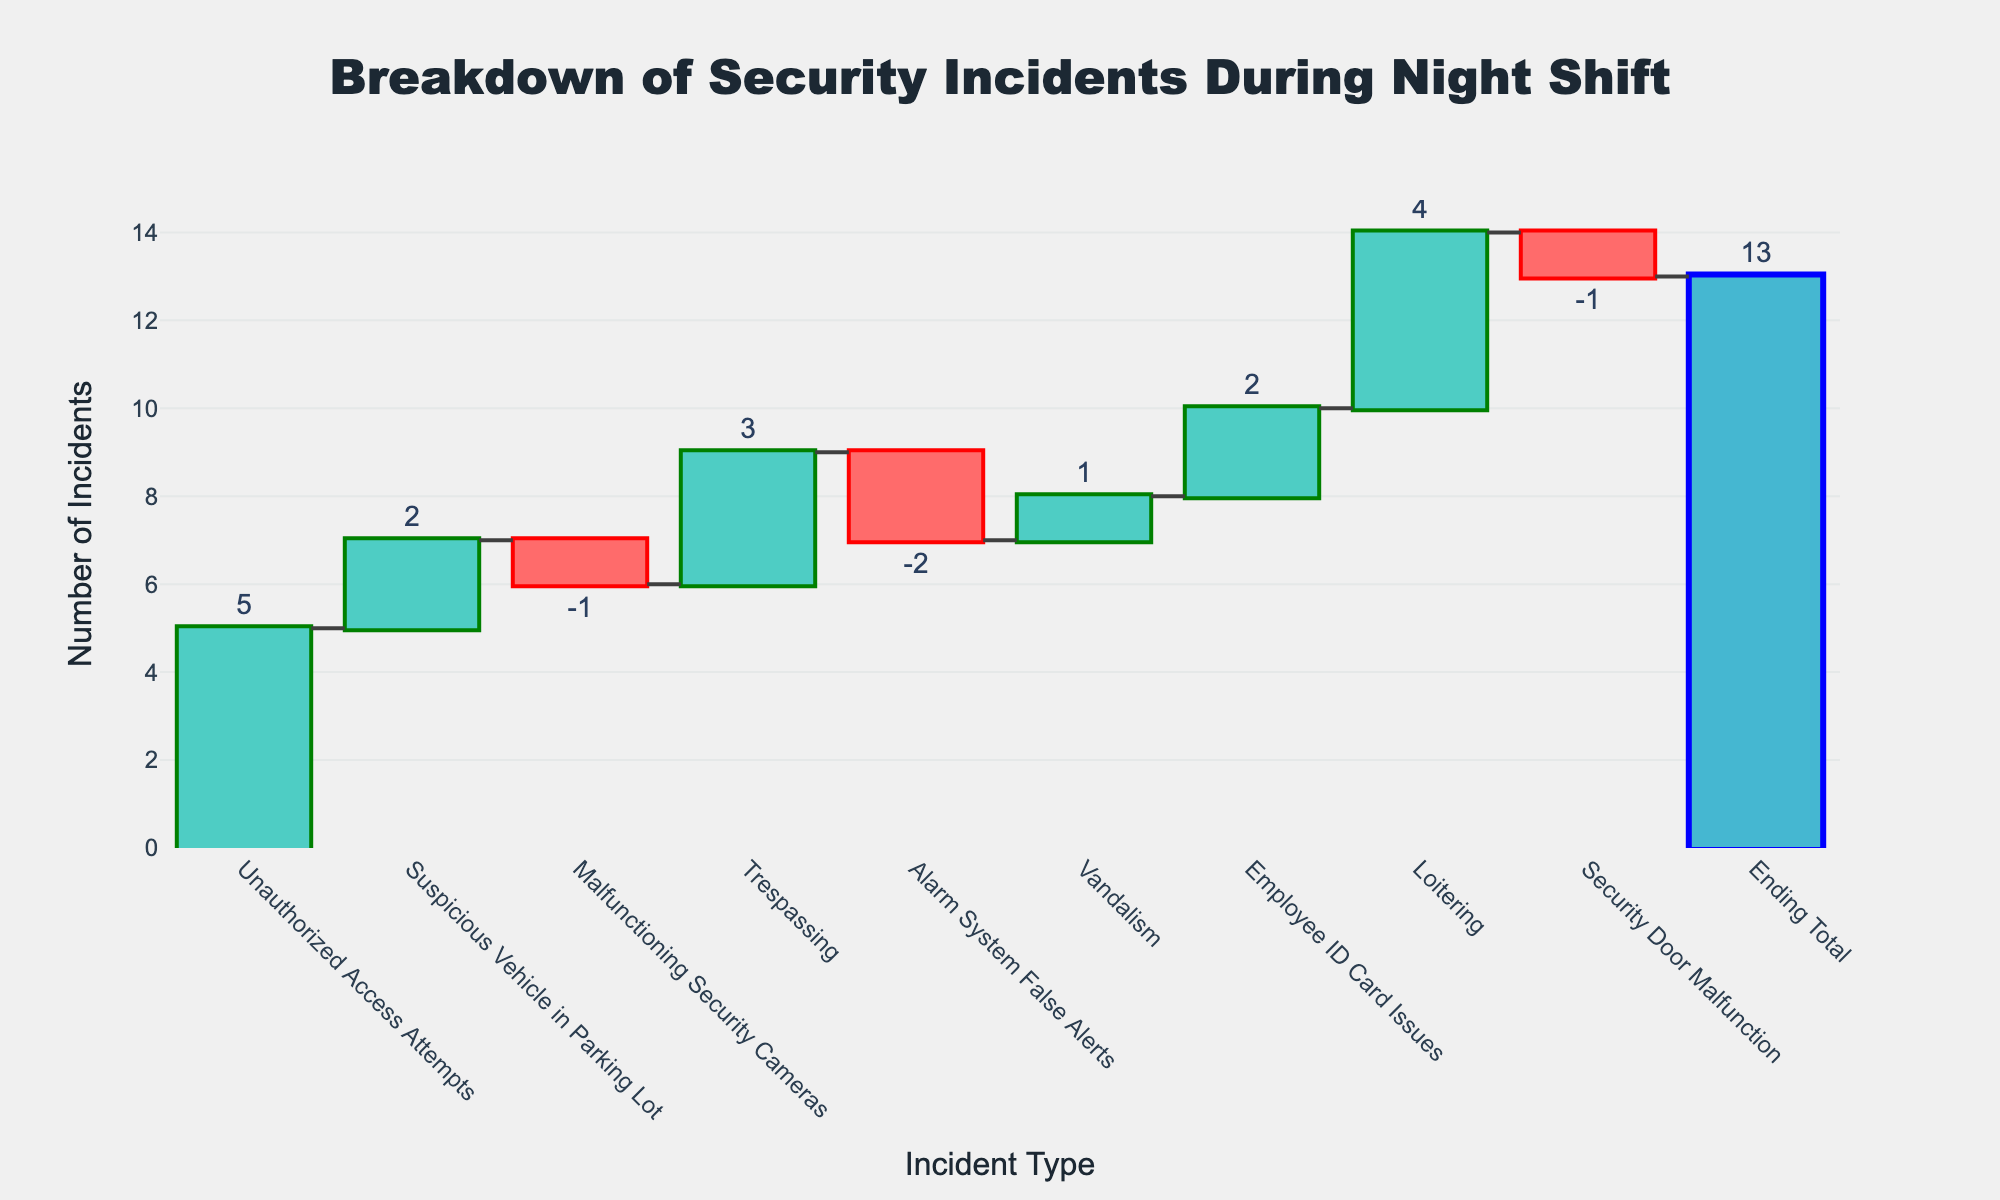What is the total number of incidents at the end of the shift? The ending total is directly indicated by the "Ending Total" bar in the chart. It represents the cumulative sum of all incidents' values.
Answer: 13 How many incidents were categorized as unauthorized access attempts? The bar labeled "Unauthorized Access Attempts" in the chart shows the value associated with this category.
Answer: 5 Which category had the lowest number of incidents? By observing the categories with negative values and comparisons between them, "Alarm System False Alerts" and "Malfunctioning Security Cameras" have the lowest values.
Answer: Alarm System False Alerts How does the sum of positive incident categories compare to the sum of negative incident categories? Positive categories: Unauthorized Access Attempts (5), Suspicious Vehicle in Parking Lot (2), Trespassing (3), Vandalism (1), Employee ID Card Issues (2), Loitering (4). Total positive = 5 + 2 + 3 + 1 + 2 + 4 = 17. Negative categories: Malfunctioning Security Cameras (-1), Alarm System False Alerts (-2), Security Door Malfunction (-1). Total negative = -1 + -2 + -1 = -4. The sum of positive incident categories is significantly higher.
Answer: 17 vs. -4 What is the cumulative number of incidents before and after accounting for the malfunctioning security cameras? The cumulative number before the malfunction is the total of preceding categories: Unauthorized Access Attempts (5) + Suspicious Vehicle in Parking Lot (2) = 7. After accounting for the malfunction, it's 7 - 1 (Malfunctioning Security Cameras) = 6.
Answer: Before: 7, After: 6 Which incident category increased the total incidents by the largest amount? By observing the bars with positive values, "Unauthorized Access Attempts" and "Loitering" both significantly increase, but "Unauthorized Access Attempts" has the highest value of 5.
Answer: Unauthorized Access Attempts Which incident categories are visualized using decreasing markers? Decreasing markers are those with negative values. The chart highlights "Malfunctioning Security Cameras," "Alarm System False Alerts," and "Security Door Malfunction" with decreasing markers.
Answer: Malfunctioning Security Cameras, Alarm System False Alerts, Security Door Malfunction How many categories have values greater than or equal to 2 incidents? Look at each bar in the chart that is 2 or greater: "Unauthorized Access Attempts" (5), "Suspicious Vehicle in Parking Lot" (2), "Trespassing" (3), "Employee ID Card Issues" (2), "Loitering" (4). There are 5 such categories.
Answer: 5 What is the difference in the number of incidents between loitering and vandalism? Loitering has a value of 4 incidents, and vandalism has a value of 1 incident. The difference is 4 - 1 = 3.
Answer: 3 